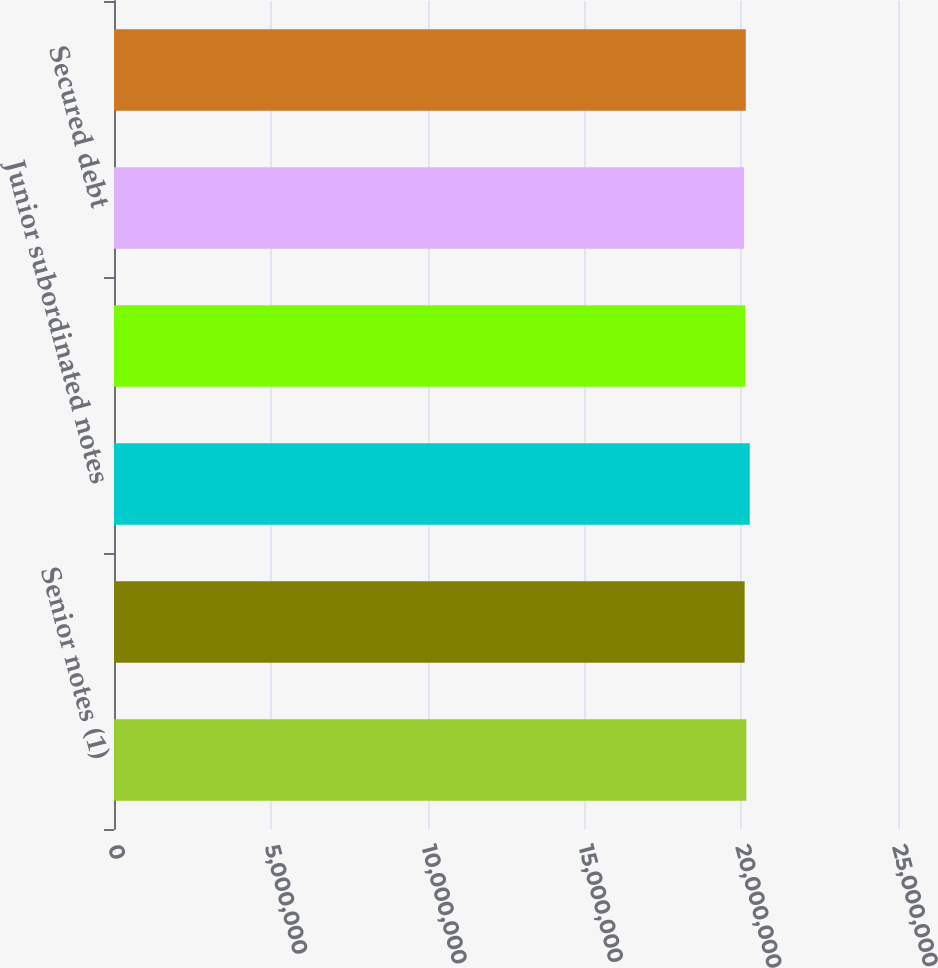Convert chart. <chart><loc_0><loc_0><loc_500><loc_500><bar_chart><fcel>Senior notes (1)<fcel>Subordinated notes<fcel>Junior subordinated notes<fcel>Senior notes (2)<fcel>Secured debt<fcel>Senior notes<nl><fcel>2.0164e+07<fcel>2.011e+07<fcel>2.02721e+07<fcel>2.0128e+07<fcel>2.0092e+07<fcel>2.0146e+07<nl></chart> 